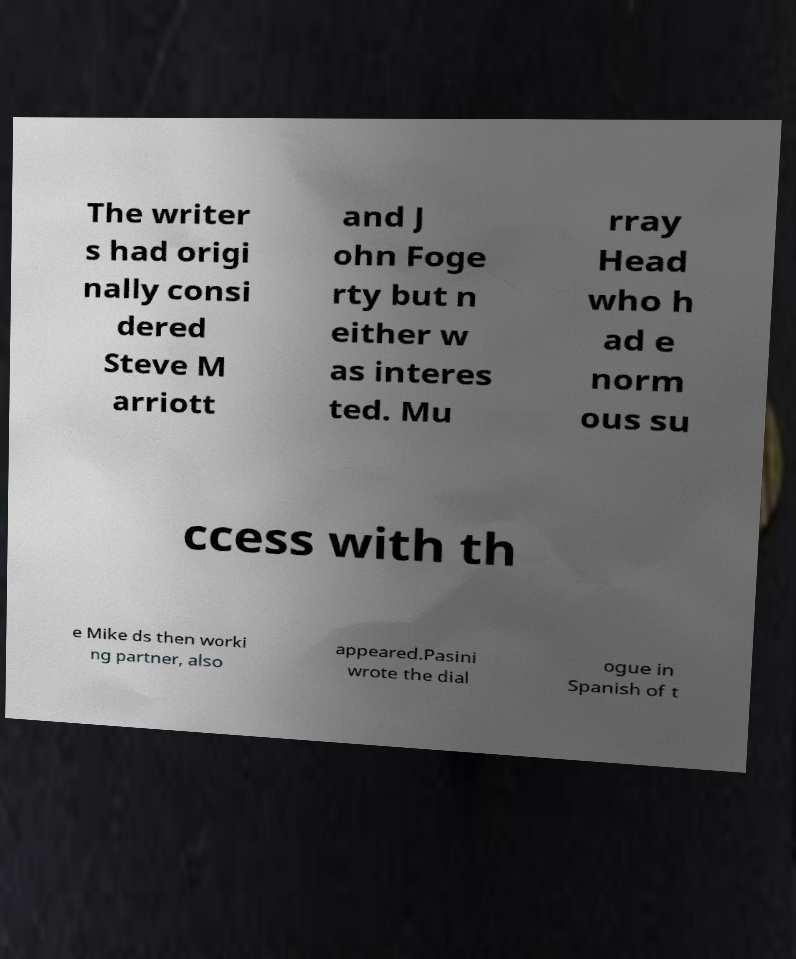For documentation purposes, I need the text within this image transcribed. Could you provide that? The writer s had origi nally consi dered Steve M arriott and J ohn Foge rty but n either w as interes ted. Mu rray Head who h ad e norm ous su ccess with th e Mike ds then worki ng partner, also appeared.Pasini wrote the dial ogue in Spanish of t 